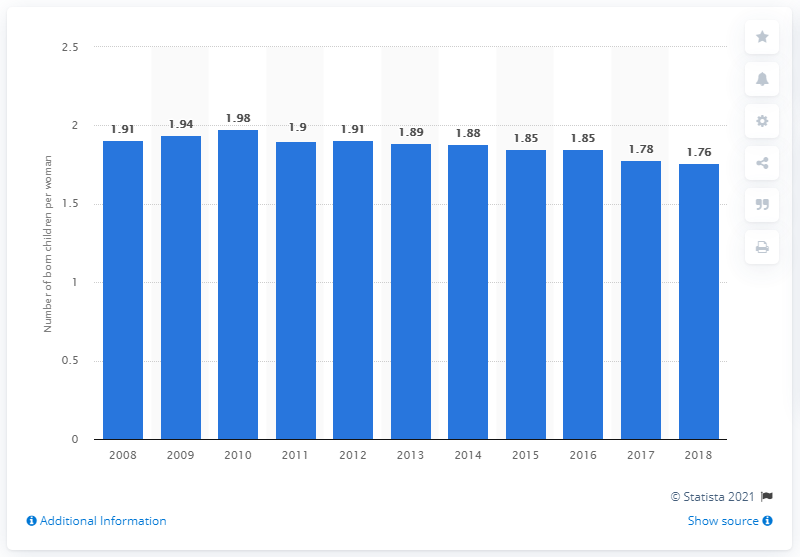Mention a couple of crucial points in this snapshot. In 2018, the fertility rate in Sweden was 1.76. 